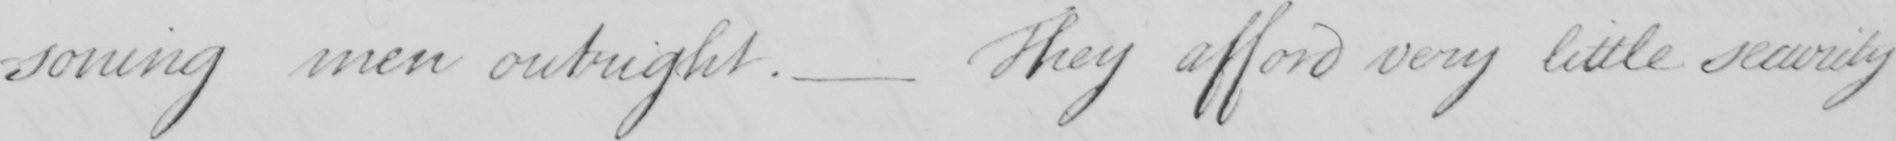Please provide the text content of this handwritten line. soning men outright .  _  They afford very little security 